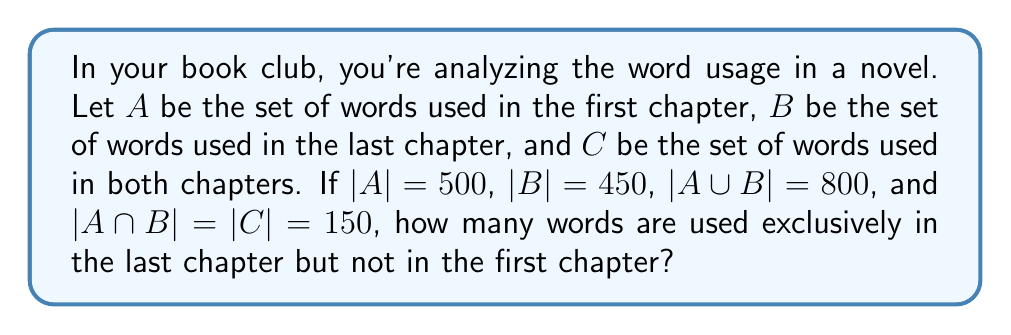Can you solve this math problem? Let's approach this step-by-step using set theory:

1) First, let's define what we're looking for. We want to find the number of words that are in $B$ but not in $A$. In set notation, this is $B \setminus A$.

2) We can use the formula for the number of elements in a union of two sets:

   $|A \cup B| = |A| + |B| - |A \cap B|$

3) We're given that $|A \cup B| = 800$, $|A| = 500$, $|B| = 450$, and $|A \cap B| = 150$. Let's verify this equation:

   $800 = 500 + 450 - 150$
   $800 = 800$ (This checks out)

4) Now, to find $|B \setminus A|$, we can use the following relationship:

   $|B| = |B \setminus A| + |A \cap B|$

5) We know $|B| = 450$ and $|A \cap B| = 150$. Let's substitute these values:

   $450 = |B \setminus A| + 150$

6) Solving for $|B \setminus A|$:

   $|B \setminus A| = 450 - 150 = 300$

Therefore, there are 300 words used exclusively in the last chapter but not in the first chapter.
Answer: 300 words 